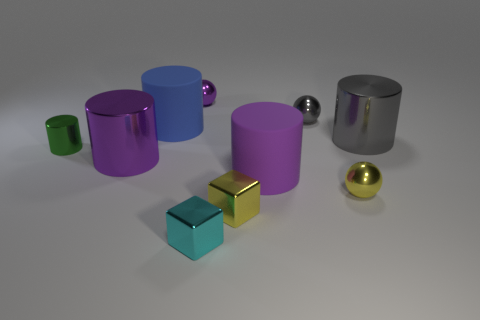How many other objects are there of the same material as the blue object?
Give a very brief answer. 1. What color is the other shiny object that is the same shape as the cyan shiny object?
Provide a short and direct response. Yellow. Are the big blue cylinder and the green cylinder made of the same material?
Give a very brief answer. No. What number of balls are large matte objects or tiny cyan shiny objects?
Make the answer very short. 0. What size is the yellow metal thing left of the small sphere in front of the purple cylinder that is right of the large purple metal cylinder?
Offer a very short reply. Small. The gray object that is the same shape as the small purple object is what size?
Provide a succinct answer. Small. How many things are in front of the big blue cylinder?
Offer a very short reply. 7. How many yellow things are either small objects or tiny metallic spheres?
Your answer should be very brief. 2. The rubber object in front of the purple shiny thing on the left side of the tiny purple object is what color?
Provide a succinct answer. Purple. What is the color of the tiny metallic ball that is to the left of the cyan block?
Give a very brief answer. Purple. 